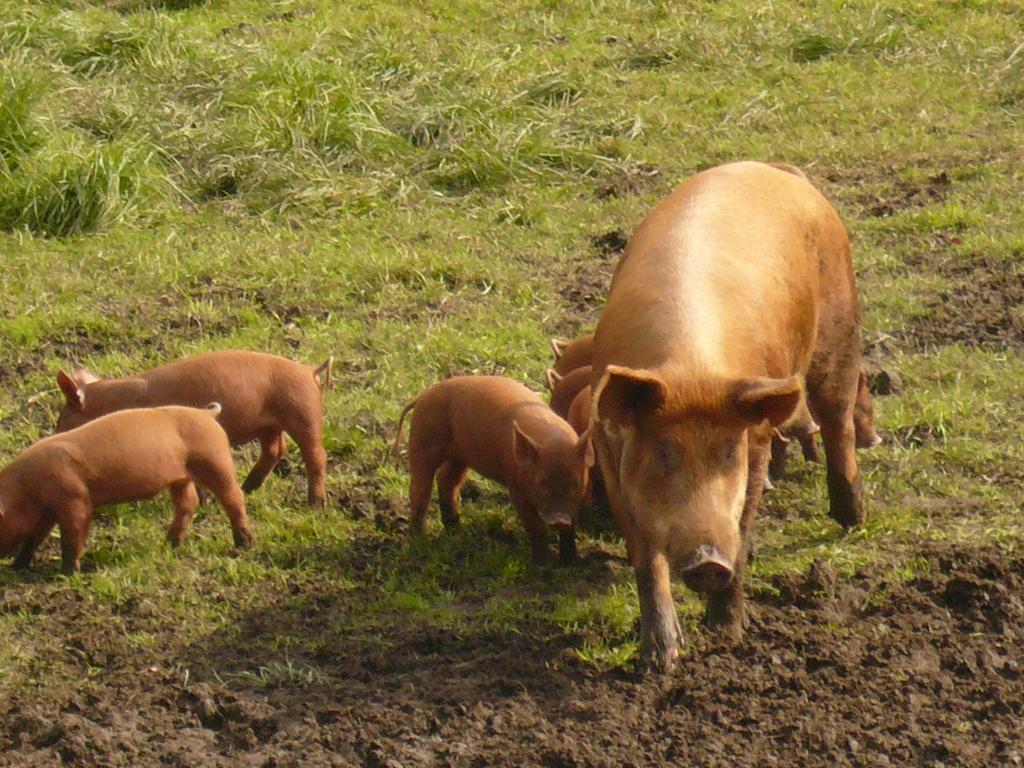Could you give a brief overview of what you see in this image? This image consists of pigs in brown color. At the bottom, there is a ground. 